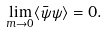Convert formula to latex. <formula><loc_0><loc_0><loc_500><loc_500>\lim _ { m \rightarrow 0 } \langle \bar { \psi } \psi \rangle = 0 .</formula> 